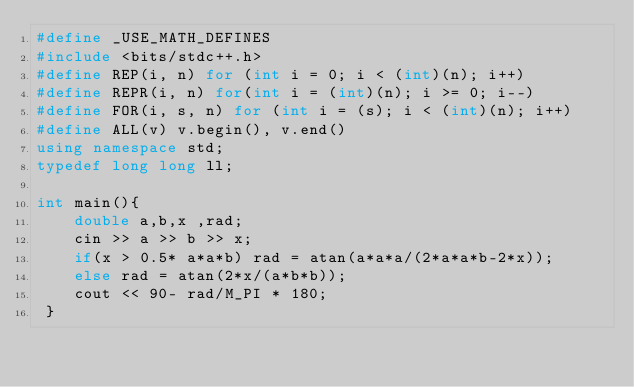Convert code to text. <code><loc_0><loc_0><loc_500><loc_500><_C++_>#define _USE_MATH_DEFINES
#include <bits/stdc++.h>
#define REP(i, n) for (int i = 0; i < (int)(n); i++)
#define REPR(i, n) for(int i = (int)(n); i >= 0; i--)
#define FOR(i, s, n) for (int i = (s); i < (int)(n); i++)
#define ALL(v) v.begin(), v.end()
using namespace std;
typedef long long ll;

int main(){
    double a,b,x ,rad;
    cin >> a >> b >> x;
    if(x > 0.5* a*a*b) rad = atan(a*a*a/(2*a*a*b-2*x));
    else rad = atan(2*x/(a*b*b));
    cout << 90- rad/M_PI * 180;
 }

</code> 